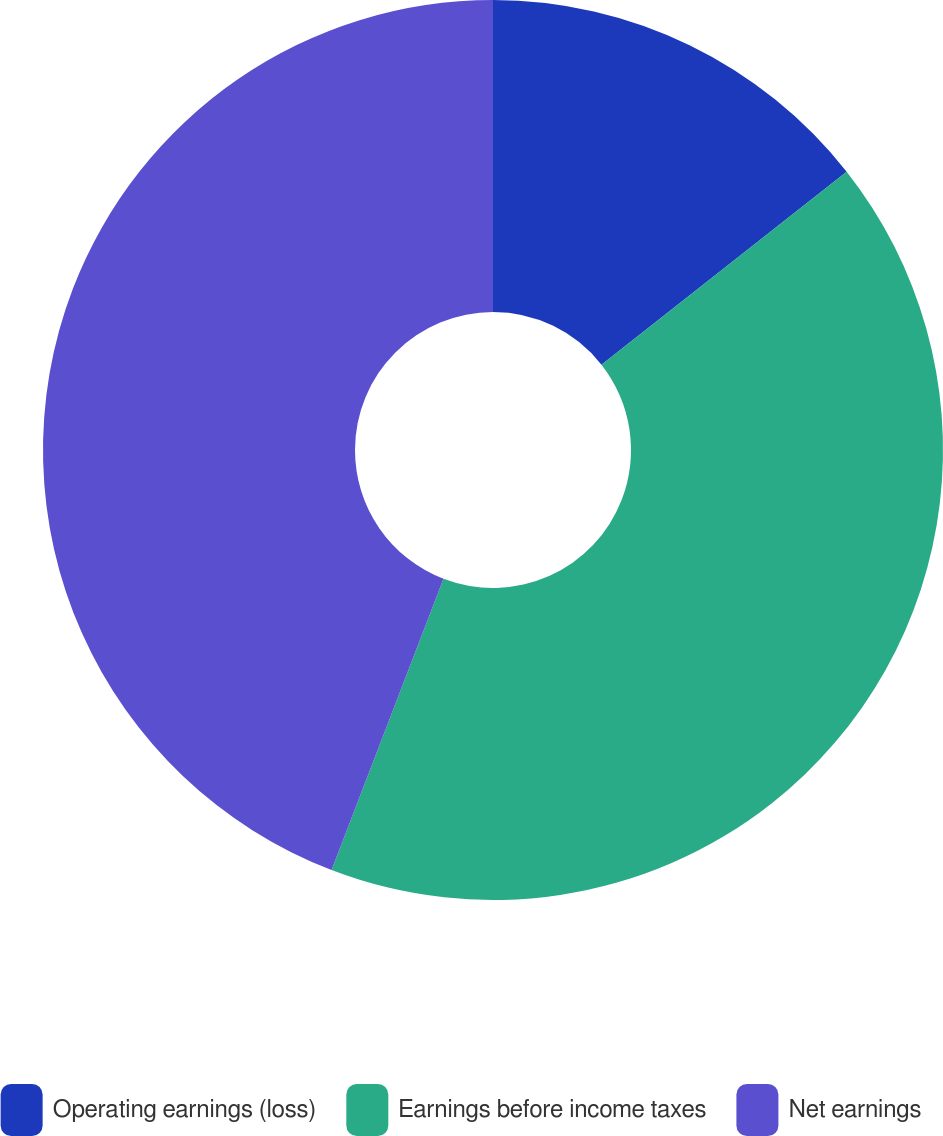Convert chart. <chart><loc_0><loc_0><loc_500><loc_500><pie_chart><fcel>Operating earnings (loss)<fcel>Earnings before income taxes<fcel>Net earnings<nl><fcel>14.39%<fcel>41.45%<fcel>44.16%<nl></chart> 